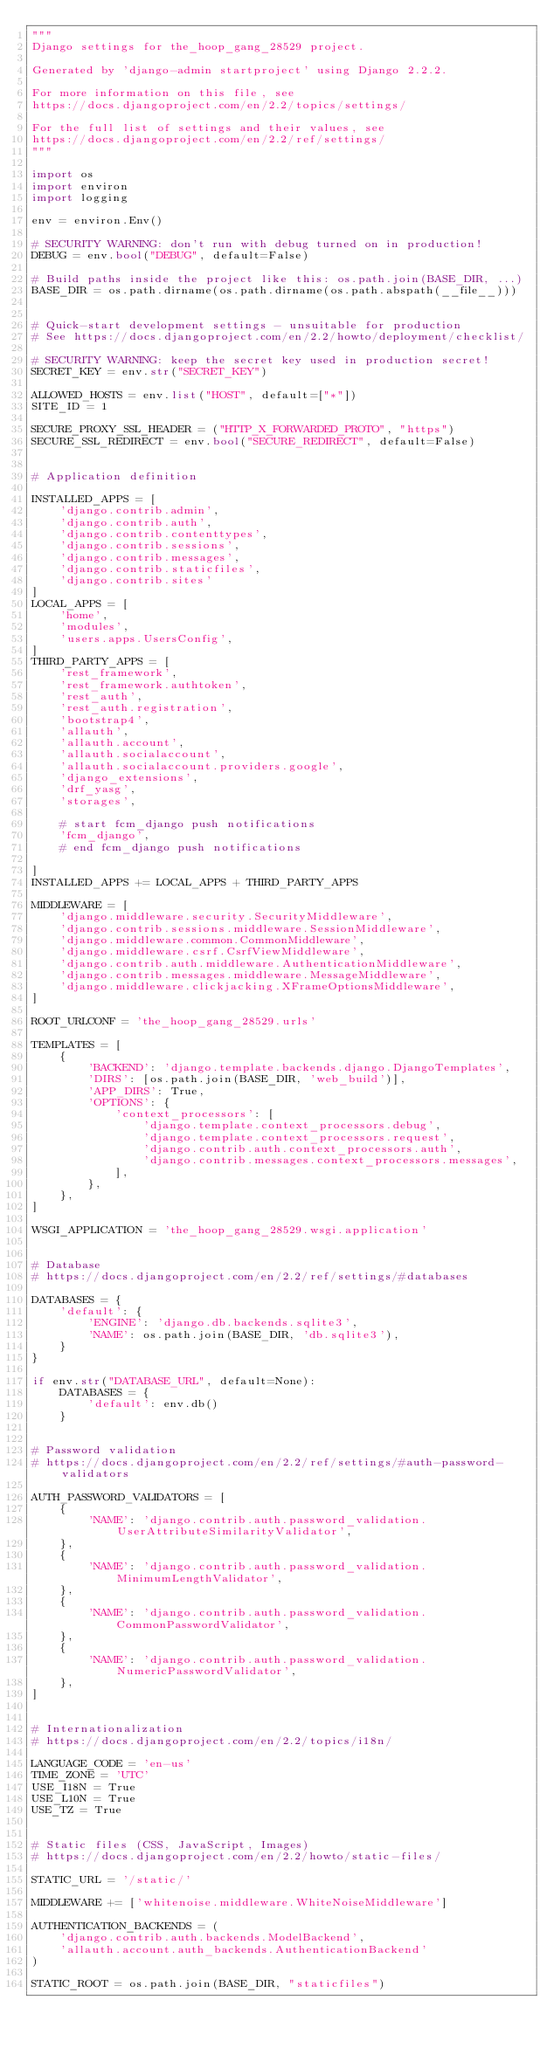<code> <loc_0><loc_0><loc_500><loc_500><_Python_>"""
Django settings for the_hoop_gang_28529 project.

Generated by 'django-admin startproject' using Django 2.2.2.

For more information on this file, see
https://docs.djangoproject.com/en/2.2/topics/settings/

For the full list of settings and their values, see
https://docs.djangoproject.com/en/2.2/ref/settings/
"""

import os
import environ
import logging

env = environ.Env()

# SECURITY WARNING: don't run with debug turned on in production!
DEBUG = env.bool("DEBUG", default=False)

# Build paths inside the project like this: os.path.join(BASE_DIR, ...)
BASE_DIR = os.path.dirname(os.path.dirname(os.path.abspath(__file__)))


# Quick-start development settings - unsuitable for production
# See https://docs.djangoproject.com/en/2.2/howto/deployment/checklist/

# SECURITY WARNING: keep the secret key used in production secret!
SECRET_KEY = env.str("SECRET_KEY")

ALLOWED_HOSTS = env.list("HOST", default=["*"])
SITE_ID = 1

SECURE_PROXY_SSL_HEADER = ("HTTP_X_FORWARDED_PROTO", "https")
SECURE_SSL_REDIRECT = env.bool("SECURE_REDIRECT", default=False)


# Application definition

INSTALLED_APPS = [
    'django.contrib.admin',
    'django.contrib.auth',
    'django.contrib.contenttypes',
    'django.contrib.sessions',
    'django.contrib.messages',
    'django.contrib.staticfiles',
    'django.contrib.sites'
]
LOCAL_APPS = [
    'home',
    'modules',
    'users.apps.UsersConfig',
]
THIRD_PARTY_APPS = [
    'rest_framework',
    'rest_framework.authtoken',
    'rest_auth',
    'rest_auth.registration',
    'bootstrap4',
    'allauth',
    'allauth.account',
    'allauth.socialaccount',
    'allauth.socialaccount.providers.google',
    'django_extensions',
    'drf_yasg',
    'storages',

    # start fcm_django push notifications
    'fcm_django',
    # end fcm_django push notifications

]
INSTALLED_APPS += LOCAL_APPS + THIRD_PARTY_APPS

MIDDLEWARE = [
    'django.middleware.security.SecurityMiddleware',
    'django.contrib.sessions.middleware.SessionMiddleware',
    'django.middleware.common.CommonMiddleware',
    'django.middleware.csrf.CsrfViewMiddleware',
    'django.contrib.auth.middleware.AuthenticationMiddleware',
    'django.contrib.messages.middleware.MessageMiddleware',
    'django.middleware.clickjacking.XFrameOptionsMiddleware',
]

ROOT_URLCONF = 'the_hoop_gang_28529.urls'

TEMPLATES = [
    {
        'BACKEND': 'django.template.backends.django.DjangoTemplates',
        'DIRS': [os.path.join(BASE_DIR, 'web_build')],
        'APP_DIRS': True,
        'OPTIONS': {
            'context_processors': [
                'django.template.context_processors.debug',
                'django.template.context_processors.request',
                'django.contrib.auth.context_processors.auth',
                'django.contrib.messages.context_processors.messages',
            ],
        },
    },
]

WSGI_APPLICATION = 'the_hoop_gang_28529.wsgi.application'


# Database
# https://docs.djangoproject.com/en/2.2/ref/settings/#databases

DATABASES = {
    'default': {
        'ENGINE': 'django.db.backends.sqlite3',
        'NAME': os.path.join(BASE_DIR, 'db.sqlite3'),
    }
}

if env.str("DATABASE_URL", default=None):
    DATABASES = {
        'default': env.db()
    }


# Password validation
# https://docs.djangoproject.com/en/2.2/ref/settings/#auth-password-validators

AUTH_PASSWORD_VALIDATORS = [
    {
        'NAME': 'django.contrib.auth.password_validation.UserAttributeSimilarityValidator',
    },
    {
        'NAME': 'django.contrib.auth.password_validation.MinimumLengthValidator',
    },
    {
        'NAME': 'django.contrib.auth.password_validation.CommonPasswordValidator',
    },
    {
        'NAME': 'django.contrib.auth.password_validation.NumericPasswordValidator',
    },
]


# Internationalization
# https://docs.djangoproject.com/en/2.2/topics/i18n/

LANGUAGE_CODE = 'en-us'
TIME_ZONE = 'UTC'
USE_I18N = True
USE_L10N = True
USE_TZ = True


# Static files (CSS, JavaScript, Images)
# https://docs.djangoproject.com/en/2.2/howto/static-files/

STATIC_URL = '/static/'

MIDDLEWARE += ['whitenoise.middleware.WhiteNoiseMiddleware']

AUTHENTICATION_BACKENDS = (
    'django.contrib.auth.backends.ModelBackend',
    'allauth.account.auth_backends.AuthenticationBackend'
)

STATIC_ROOT = os.path.join(BASE_DIR, "staticfiles")</code> 